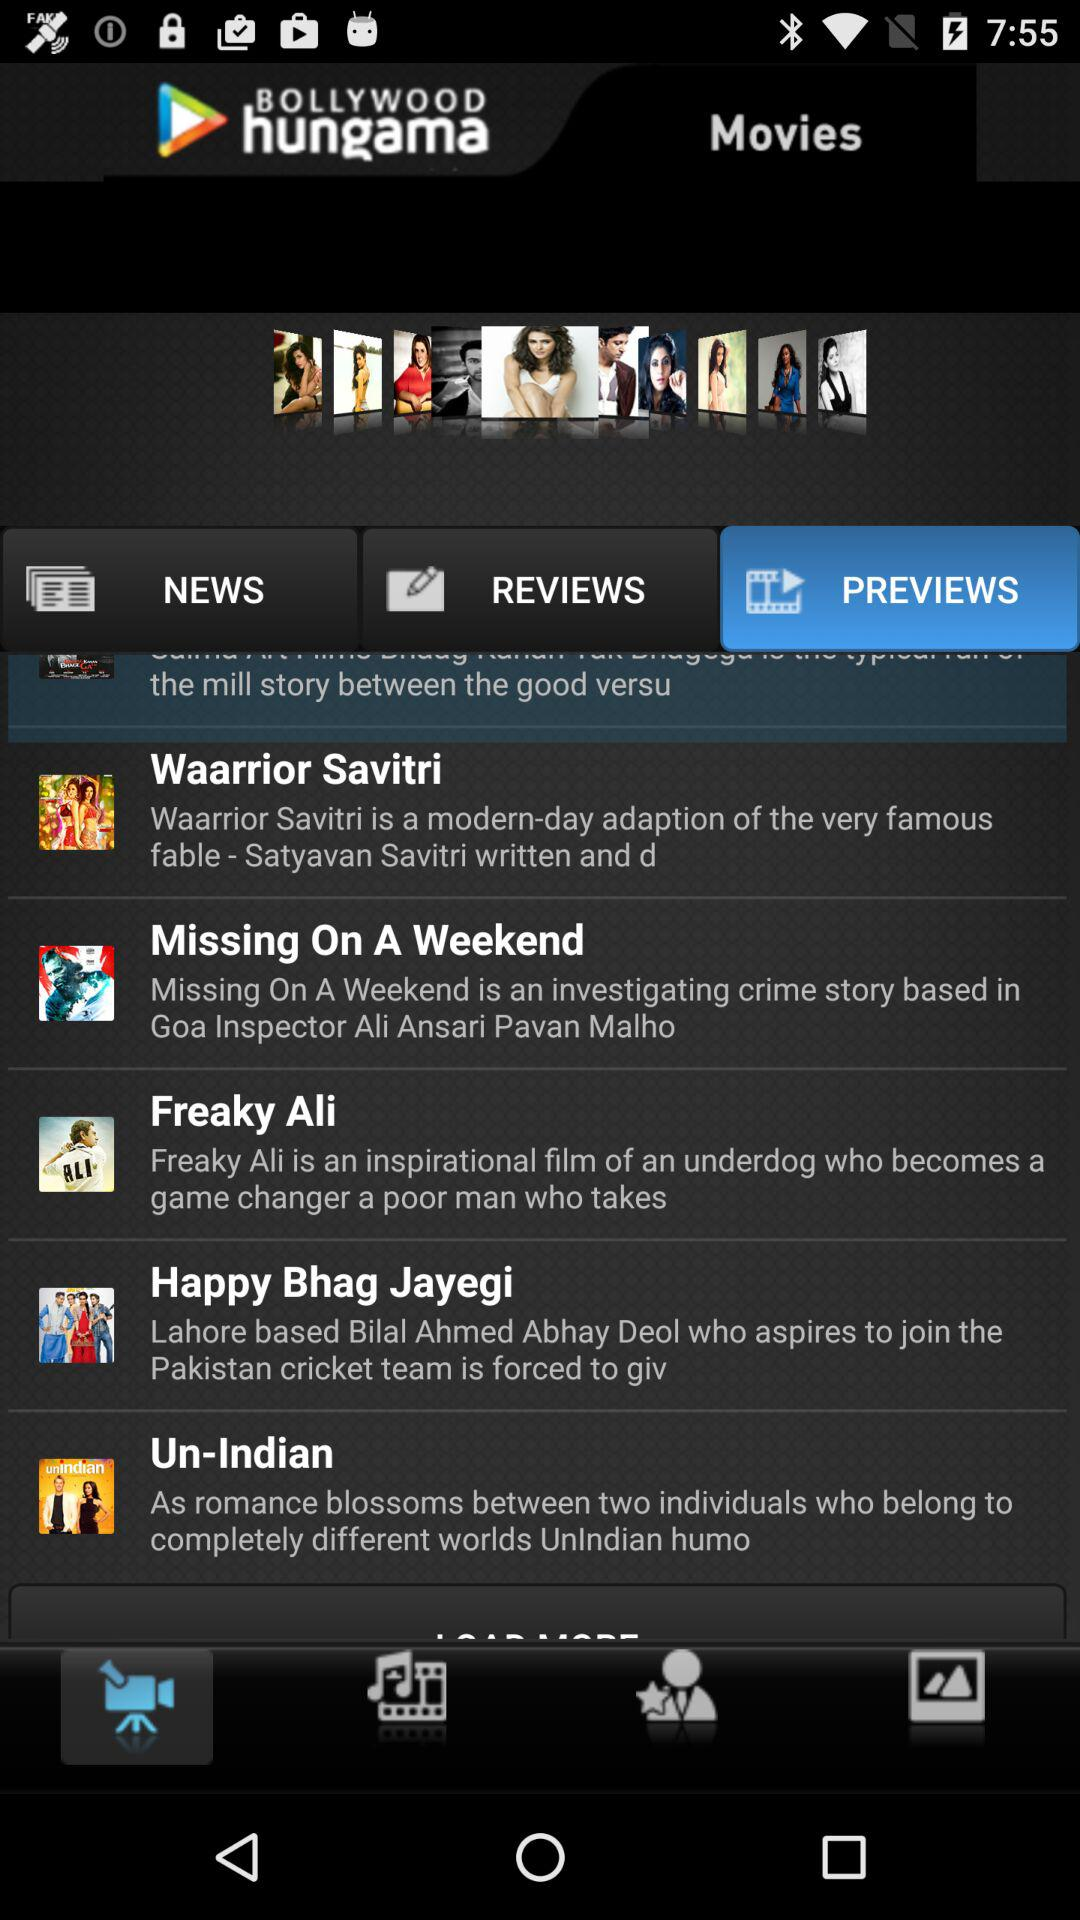What is the application name? The application name is "BOLLYWOOD hungama". 